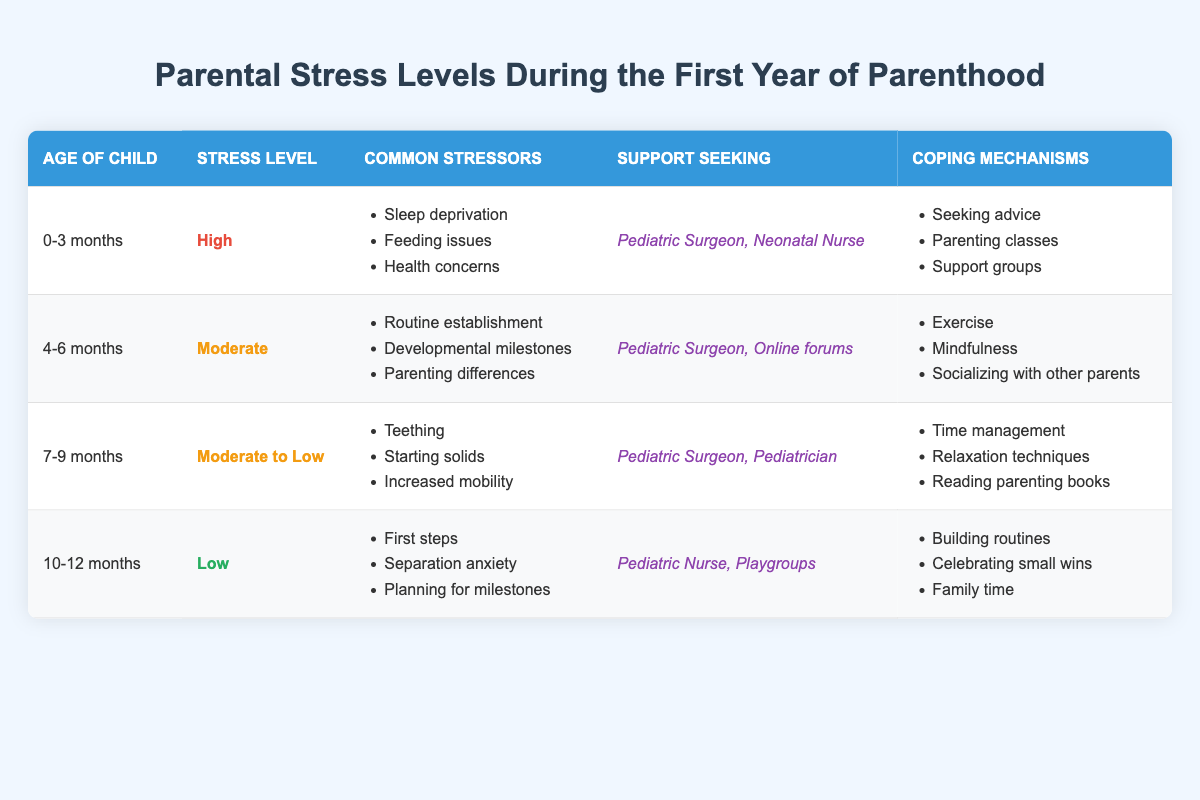What is the stress level for a child aged 0-3 months? According to the table, the stress level for a child aged 0-3 months is classified as "High."
Answer: High What are the common stressors for parents during the 4-6 months age range? The common stressors listed for the 4-6 months age range include "Routine establishment," "Developmental milestones," and "Parenting differences."
Answer: Routine establishment, Developmental milestones, Parenting differences Is "Separation anxiety" a stressor for parents with children aged 10-12 months? Yes, "Separation anxiety" is mentioned as a common stressor for parents of children aged 10-12 months.
Answer: Yes Which support resources do parents seek for children aged 7-9 months? Parents of children aged 7-9 months seek support from "Pediatric Surgeon" and "Pediatrician."
Answer: Pediatric Surgeon, Pediatrician What coping mechanisms do parents often use when their child is 4-6 months old? The coping mechanisms for parents of children aged 4-6 months include "Exercise," "Mindfulness," and "Socializing with other parents."
Answer: Exercise, Mindfulness, Socializing with other parents What is the difference in stress levels between the age ranges of 0-3 months and 10-12 months? The stress level for children aged 0-3 months is "High," while for children aged 10-12 months it is "Low." This indicates a difference in stress levels of two levels downwards.
Answer: Two levels Are parents more likely to seek support from a Neonatal Nurse or an Online forum when their child is 4-6 months old? Parents are more likely to seek support from an Online forum for children aged 4-6 months, as they are listed as the support resources for that age range.
Answer: Online forum How do parental stress levels change from 0-3 months to 10-12 months? Parental stress levels decrease from "High" at 0-3 months to "Low" at 10-12 months, indicating a general trend of reduced stress as the child grows.
Answer: Decrease If a parent is struggling with teething at 7-9 months, which support resource could they seek? For parents struggling with teething when their child is 7-9 months old, they could seek support from a "Pediatric Surgeon" or a "Pediatrician."
Answer: Pediatric Surgeon, Pediatrician What are some coping mechanisms listed for parents during the last three months? The coping mechanisms for the 10-12 months age range include "Building routines," "Celebrating small wins," and "Family time."
Answer: Building routines, Celebrating small wins, Family time What is the median stress level across all age groups? The stress levels are High, Moderate, Moderate to Low, and Low. Arranging them gives us High, Moderate, Moderate to Low, Low; the median (middle value) is "Moderate."
Answer: Moderate 